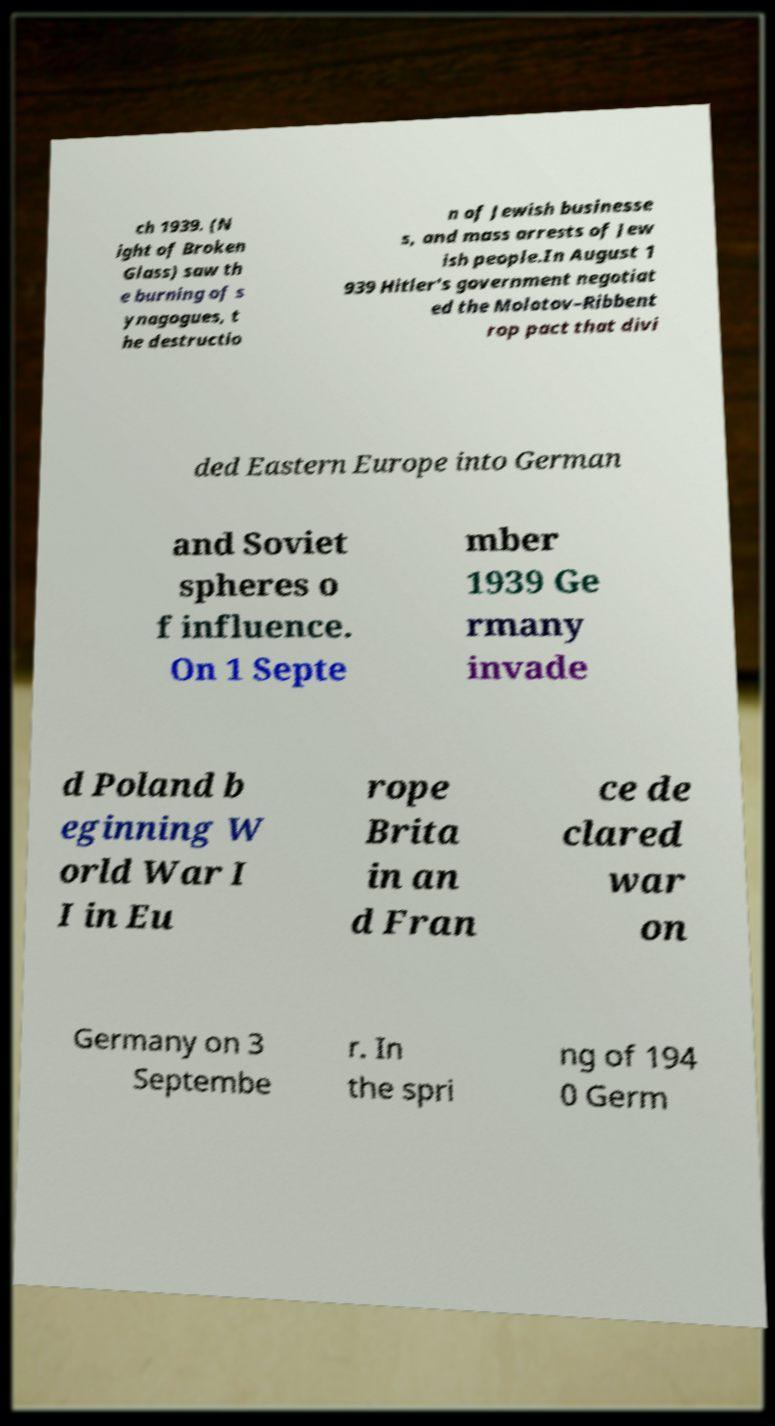Can you read and provide the text displayed in the image?This photo seems to have some interesting text. Can you extract and type it out for me? ch 1939. (N ight of Broken Glass) saw th e burning of s ynagogues, t he destructio n of Jewish businesse s, and mass arrests of Jew ish people.In August 1 939 Hitler's government negotiat ed the Molotov–Ribbent rop pact that divi ded Eastern Europe into German and Soviet spheres o f influence. On 1 Septe mber 1939 Ge rmany invade d Poland b eginning W orld War I I in Eu rope Brita in an d Fran ce de clared war on Germany on 3 Septembe r. In the spri ng of 194 0 Germ 